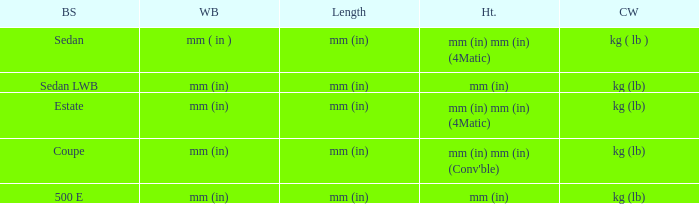What's the length of the model with Sedan body style? Mm (in). 